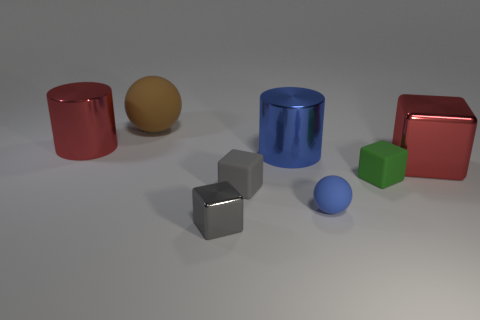What number of shiny things are either cyan cylinders or tiny balls? In the image, there is one cyan cylinder and one tiny blue ball, making the total number of shiny things that are either cyan cylinders or tiny balls to be two. 